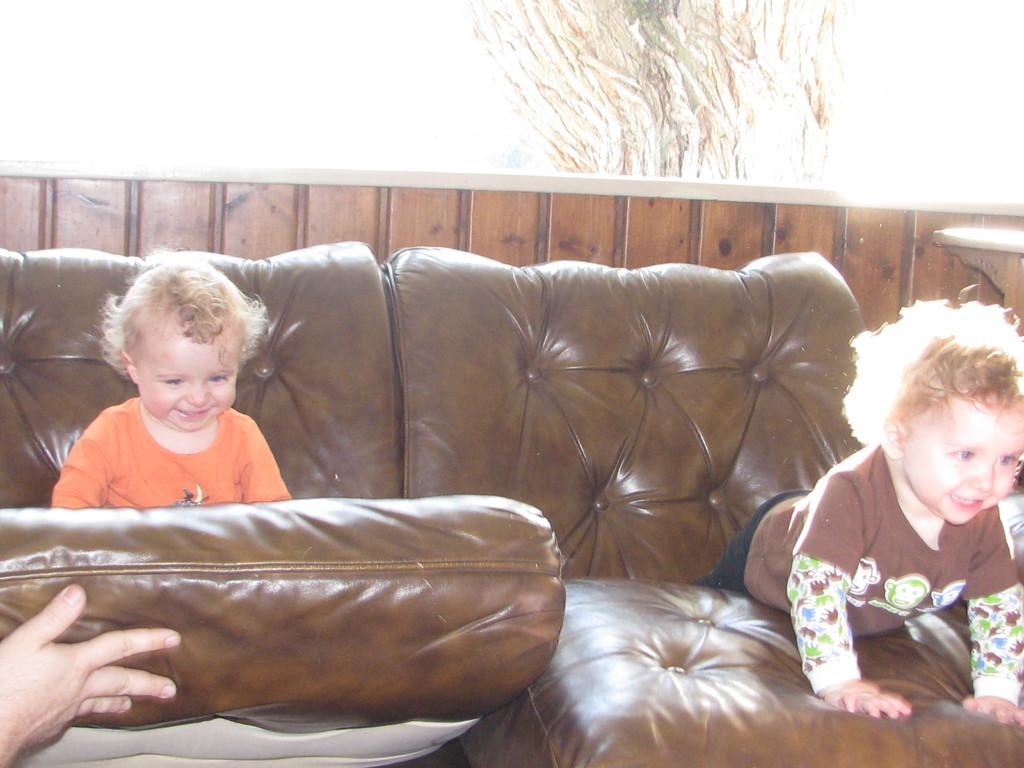What type of furniture is in the image? There is a couch in the image. How many babies are present in the image? There are two babies in the image. What are the babies doing on the couch? The babies are playing on the couch. Can you describe the interaction between one of the babies and the couch? One of the babies is holding the couch with one hand. What type of squirrel can be seen climbing the couch in the image? There is no squirrel present in the image; it features a couch and two babies playing on it. 